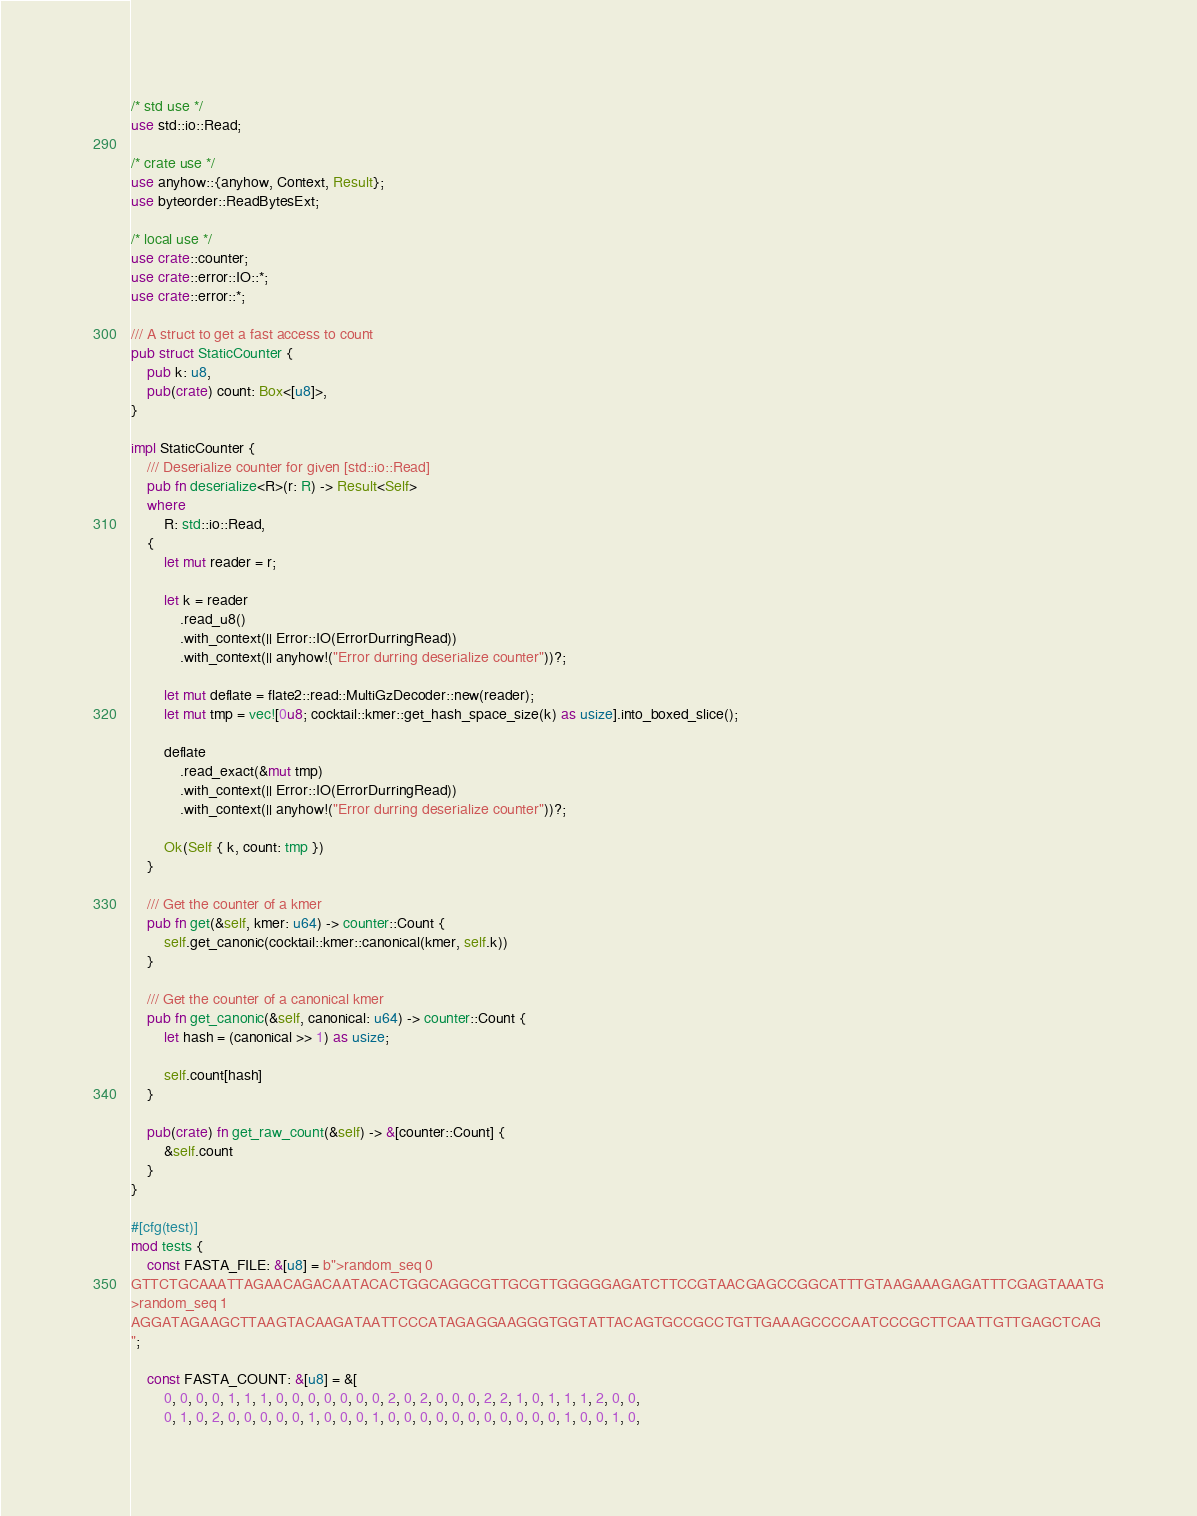<code> <loc_0><loc_0><loc_500><loc_500><_Rust_>/* std use */
use std::io::Read;

/* crate use */
use anyhow::{anyhow, Context, Result};
use byteorder::ReadBytesExt;

/* local use */
use crate::counter;
use crate::error::IO::*;
use crate::error::*;

/// A struct to get a fast access to count
pub struct StaticCounter {
    pub k: u8,
    pub(crate) count: Box<[u8]>,
}

impl StaticCounter {
    /// Deserialize counter for given [std::io::Read]
    pub fn deserialize<R>(r: R) -> Result<Self>
    where
        R: std::io::Read,
    {
        let mut reader = r;

        let k = reader
            .read_u8()
            .with_context(|| Error::IO(ErrorDurringRead))
            .with_context(|| anyhow!("Error durring deserialize counter"))?;

        let mut deflate = flate2::read::MultiGzDecoder::new(reader);
        let mut tmp = vec![0u8; cocktail::kmer::get_hash_space_size(k) as usize].into_boxed_slice();

        deflate
            .read_exact(&mut tmp)
            .with_context(|| Error::IO(ErrorDurringRead))
            .with_context(|| anyhow!("Error durring deserialize counter"))?;

        Ok(Self { k, count: tmp })
    }

    /// Get the counter of a kmer
    pub fn get(&self, kmer: u64) -> counter::Count {
        self.get_canonic(cocktail::kmer::canonical(kmer, self.k))
    }

    /// Get the counter of a canonical kmer
    pub fn get_canonic(&self, canonical: u64) -> counter::Count {
        let hash = (canonical >> 1) as usize;

        self.count[hash]
    }

    pub(crate) fn get_raw_count(&self) -> &[counter::Count] {
        &self.count
    }
}

#[cfg(test)]
mod tests {
    const FASTA_FILE: &[u8] = b">random_seq 0
GTTCTGCAAATTAGAACAGACAATACACTGGCAGGCGTTGCGTTGGGGGAGATCTTCCGTAACGAGCCGGCATTTGTAAGAAAGAGATTTCGAGTAAATG
>random_seq 1
AGGATAGAAGCTTAAGTACAAGATAATTCCCATAGAGGAAGGGTGGTATTACAGTGCCGCCTGTTGAAAGCCCCAATCCCGCTTCAATTGTTGAGCTCAG
";

    const FASTA_COUNT: &[u8] = &[
        0, 0, 0, 0, 1, 1, 1, 0, 0, 0, 0, 0, 0, 0, 2, 0, 2, 0, 0, 0, 2, 2, 1, 0, 1, 1, 1, 2, 0, 0,
        0, 1, 0, 2, 0, 0, 0, 0, 0, 1, 0, 0, 0, 1, 0, 0, 0, 0, 0, 0, 0, 0, 0, 0, 0, 1, 0, 0, 1, 0,</code> 